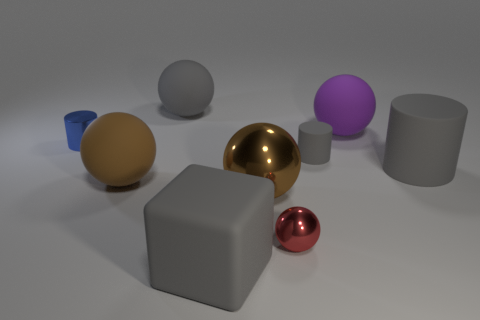The big metallic thing that is the same shape as the large brown matte thing is what color?
Ensure brevity in your answer.  Brown. Are there fewer gray cubes to the left of the tiny metal cylinder than gray matte cylinders?
Offer a terse response. Yes. Does the red ball have the same material as the tiny cylinder that is left of the tiny rubber cylinder?
Your answer should be very brief. Yes. Are there any matte things right of the large brown sphere that is to the left of the thing that is behind the large purple thing?
Your answer should be compact. Yes. What color is the big ball that is made of the same material as the red thing?
Keep it short and to the point. Brown. There is a thing that is both to the right of the gray cube and in front of the big metal sphere; what size is it?
Your answer should be very brief. Small. Are there fewer big gray blocks behind the large gray rubber cube than large objects that are to the left of the big brown shiny object?
Ensure brevity in your answer.  Yes. Is the material of the brown sphere that is in front of the big brown rubber thing the same as the large ball that is on the left side of the big gray rubber ball?
Your response must be concise. No. What is the material of the large ball that is the same color as the cube?
Your response must be concise. Rubber. What shape is the tiny thing that is both behind the big gray cylinder and to the right of the brown rubber object?
Your answer should be very brief. Cylinder. 